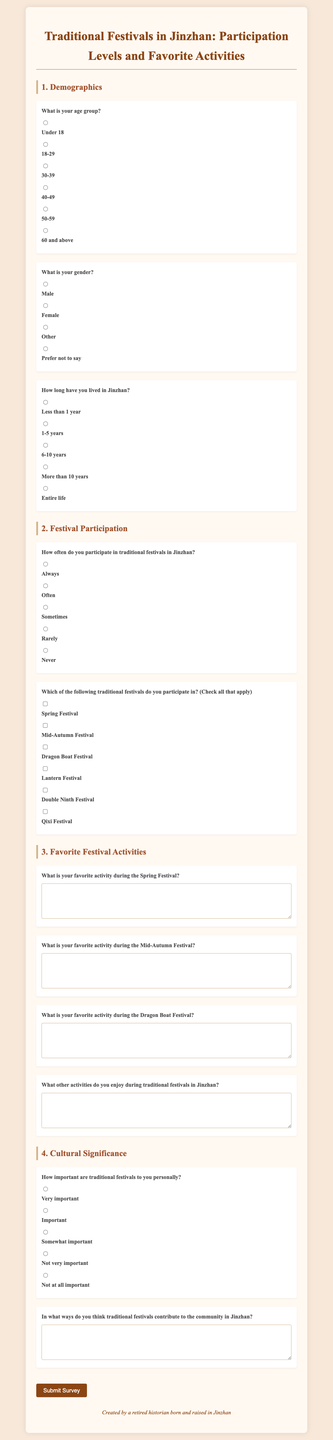What is the title of the survey? The title of the survey is displayed at the top of the document, which reads "Traditional Festivals in Jinzhan: Participation Levels and Favorite Activities."
Answer: Traditional Festivals in Jinzhan: Participation Levels and Favorite Activities What are the age groups listed in the survey? The survey provides six age group options for respondents to select from, which are listed under the demographics section.
Answer: Under 18, 18-29, 30-39, 40-49, 50-59, 60 and above How many traditional festivals can respondents select in the participation section? In the participation section, respondents are asked to check all relevant festivals, and six options are provided for selection.
Answer: Six What is the first activity respondents can mention for the Spring Festival? The first activity prompt specifically asks respondents for their favorite activity during the Spring Festival, which is notable from the questions section.
Answer: What is your favorite activity during the Spring Festival? What response options are available regarding the importance of traditional festivals personally? The document presents five response options concerning personal importance, which help gauge respondents' sentiments.
Answer: Very important, Important, Somewhat important, Not very important, Not at all important How long can respondents indicate they have lived in Jinzhan? The survey offers five options regarding the length of residency in Jinzhan, allowing respondents to choose their respective duration.
Answer: Less than 1 year, 1-5 years, 6-10 years, More than 10 years, Entire life What is the purpose of the text area for community contribution? The survey includes a text area where respondents can elaborate on how traditional festivals contribute to the community in Jinzhan.
Answer: In what ways do you think traditional festivals contribute to the community in Jinzhan? 